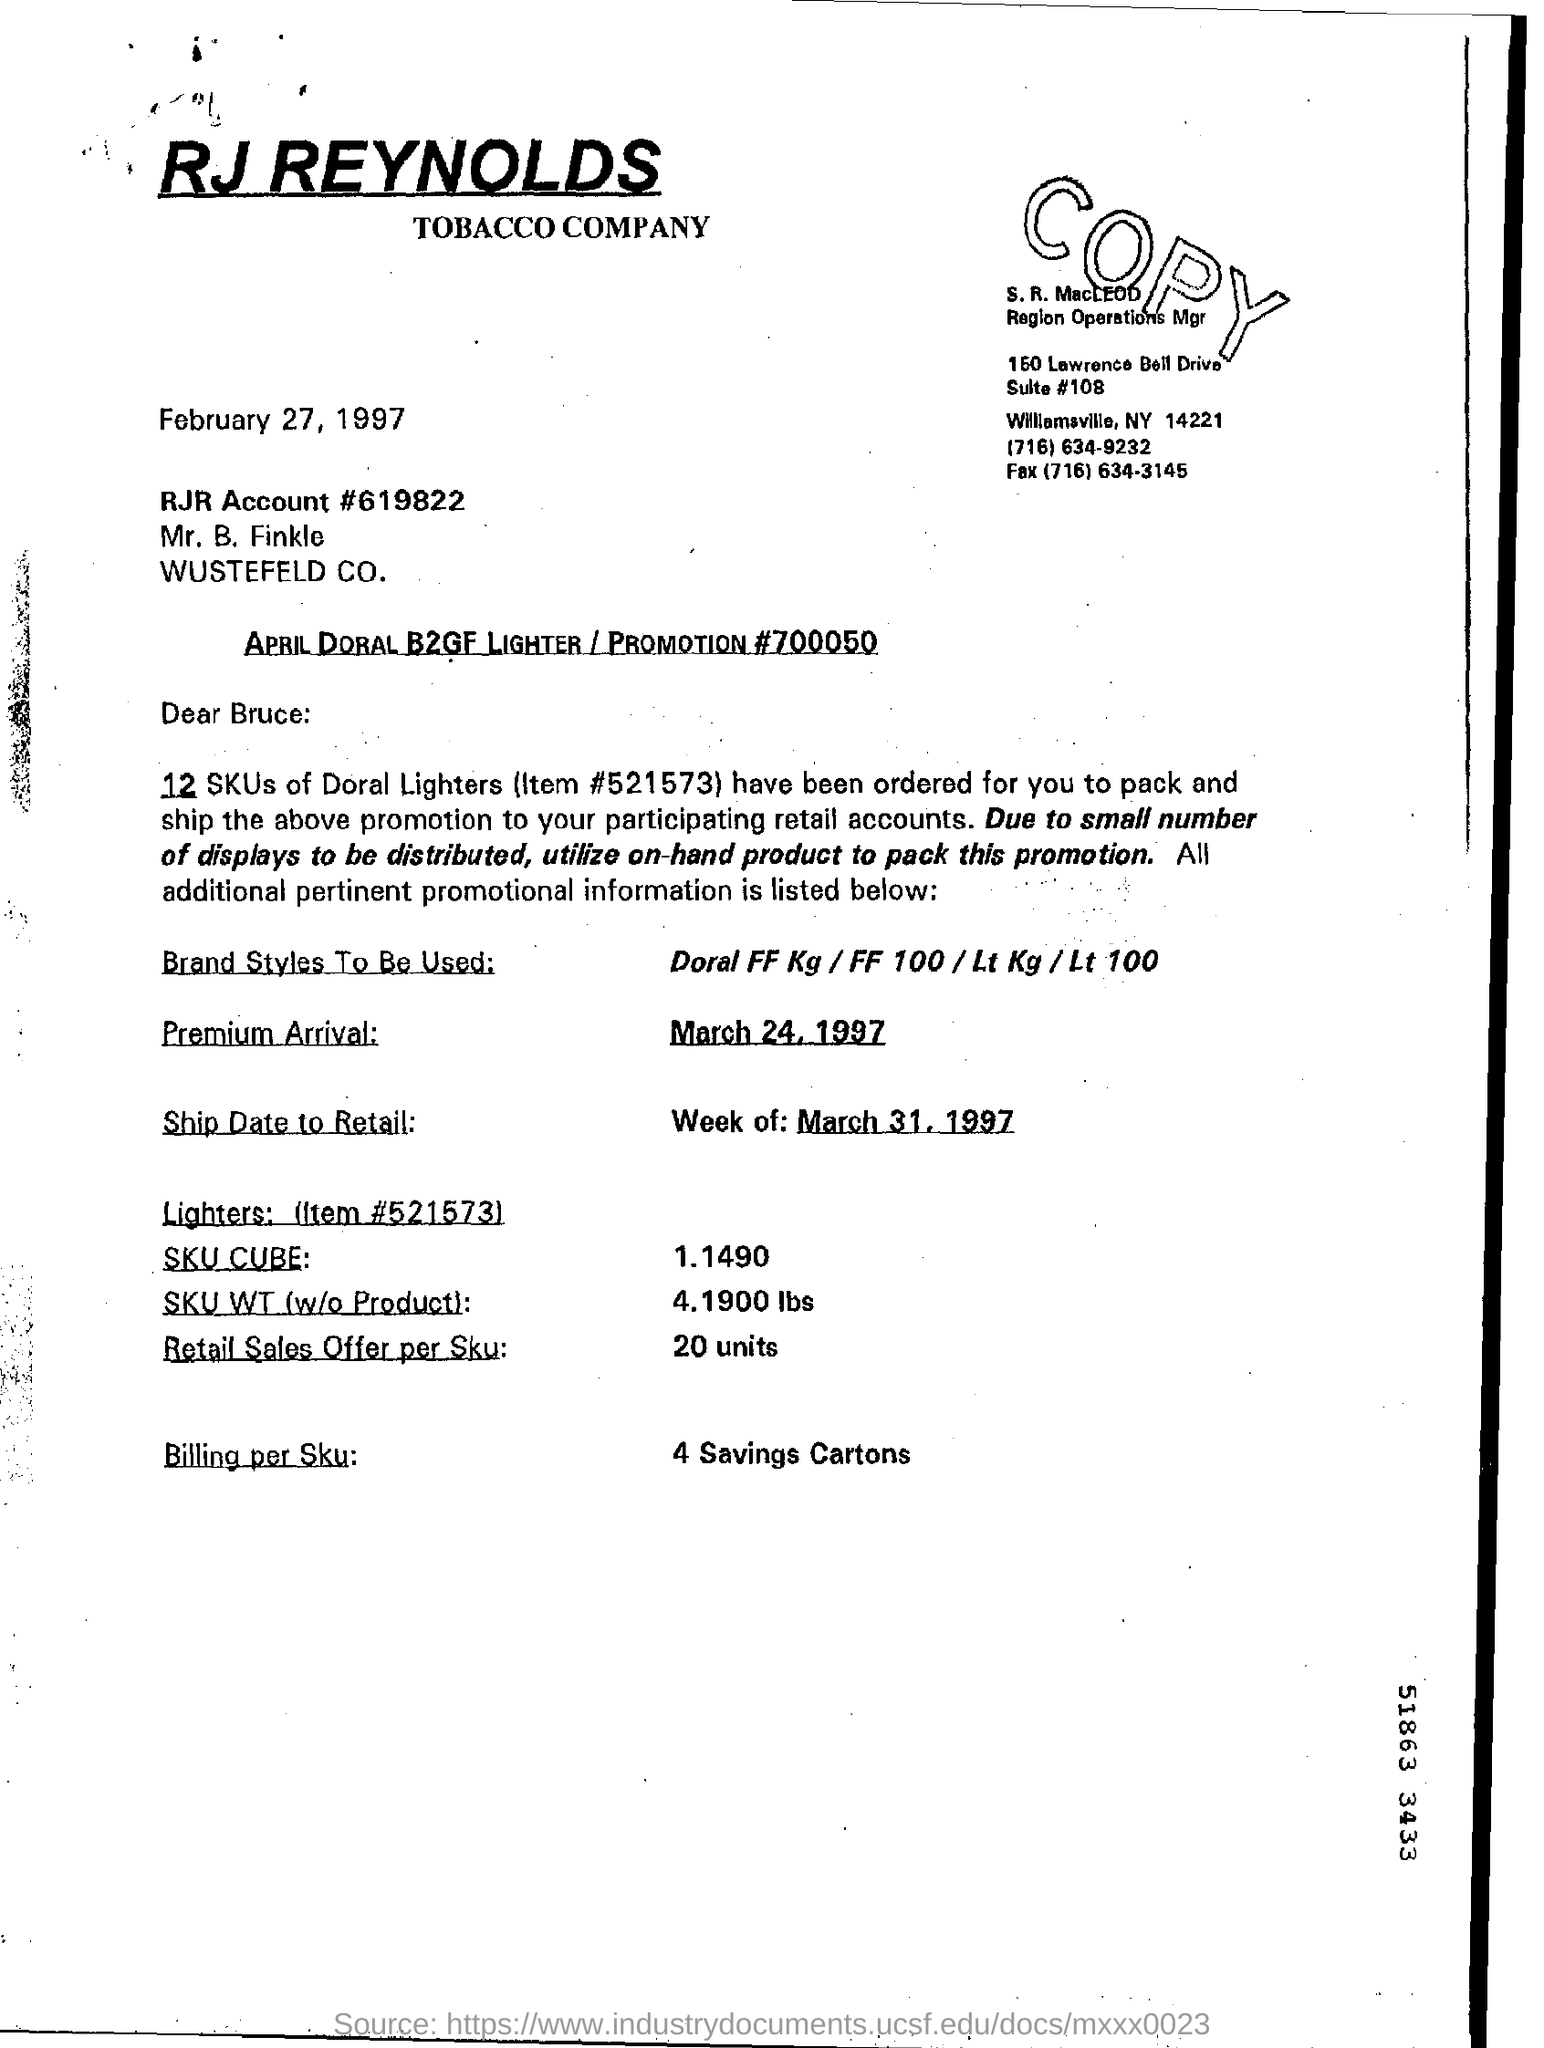What is the Item # of Doral Lighters?
Offer a very short reply. #521573. When is the Premium arrival date?
Offer a terse response. March 24, 1997. How much is the Retail Sales Offer per Sku?
Make the answer very short. 20 units. 